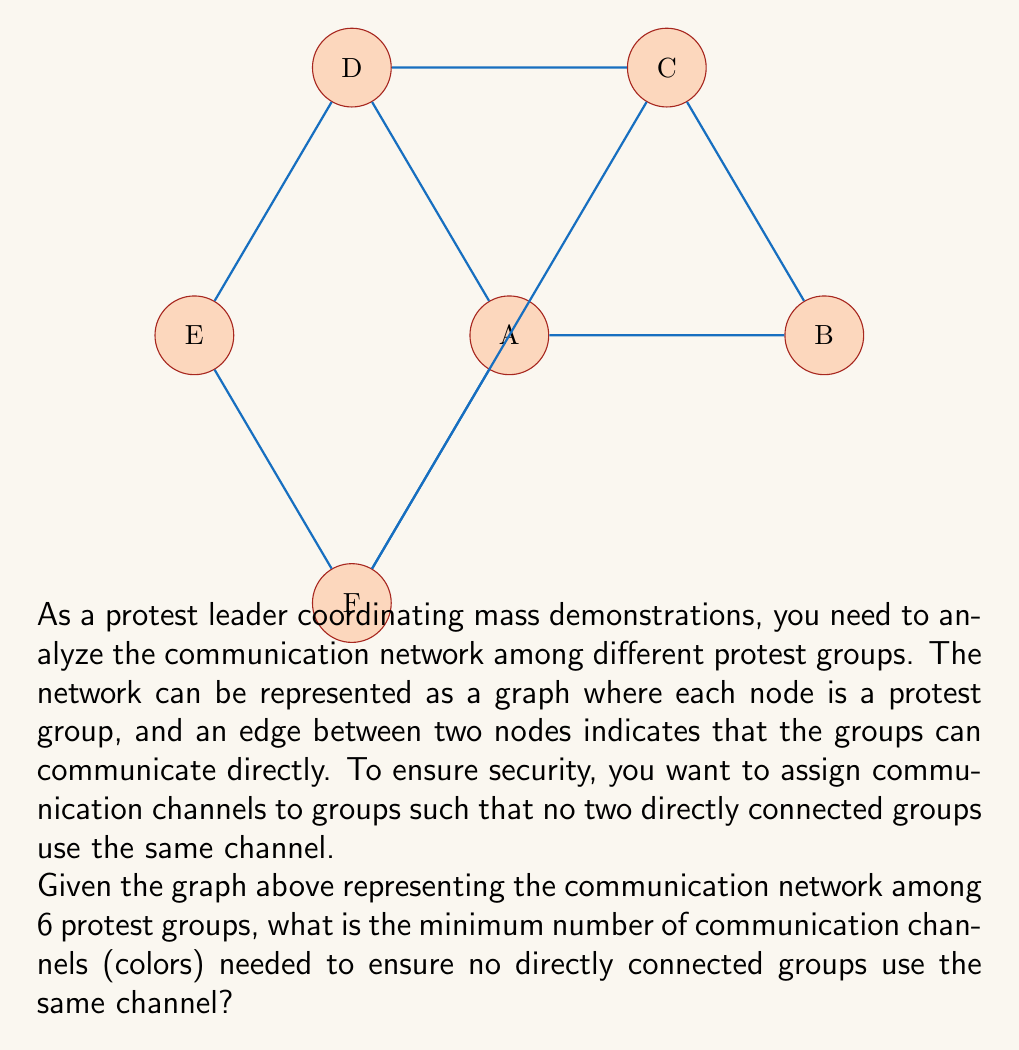Can you answer this question? To solve this problem, we need to use the concept of graph coloring. The minimum number of colors required to color a graph such that no two adjacent vertices have the same color is called the chromatic number of the graph.

Let's approach this step-by-step:

1) First, we observe that the graph has a cycle of odd length (A-B-C-D-E-F-A), which is a 6-cycle. This immediately tells us that we need at least 3 colors.

2) Let's try to color the graph with 3 colors:
   - Assign color 1 to A
   - B must be different, so assign color 2 to B
   - C must be different from B, so assign color 3 to C
   - D must be different from C and A, so assign color 2 to D
   - E must be different from D, so assign color 1 to E
   - F must be different from E and A, so assign color 3 to F

3) We can verify that this coloring is valid:
   - A (1) is adjacent to B (2), F (3), D (2)
   - B (2) is adjacent to A (1), C (3)
   - C (3) is adjacent to B (2), D (2), F (3)
   - D (2) is adjacent to C (3), E (1), A (1)
   - E (1) is adjacent to D (2), F (3)
   - F (3) is adjacent to E (1), A (1), C (3)

4) Since we found a valid 3-coloring, and we know that at least 3 colors are needed due to the odd cycle, we can conclude that the chromatic number of this graph is 3.

Therefore, the minimum number of communication channels needed is 3.
Answer: 3 